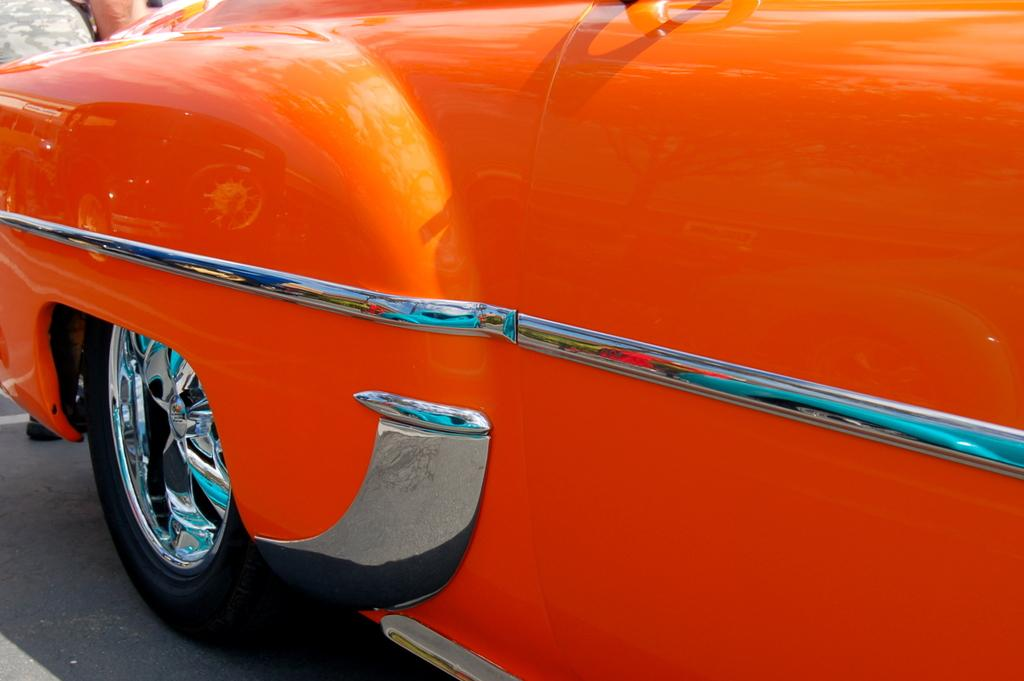What color is the car in the image? The car in the image is orange. Where is the car located in the image? The car is on the road. Is there anyone else present in the image besides the car? Yes, there is a person standing on the road. What type of texture does the sock have in the image? There is no sock present in the image. Who is the father of the person standing on the road in the image? The provided facts do not mention any information about the person's father, so it cannot be determined from the image. 